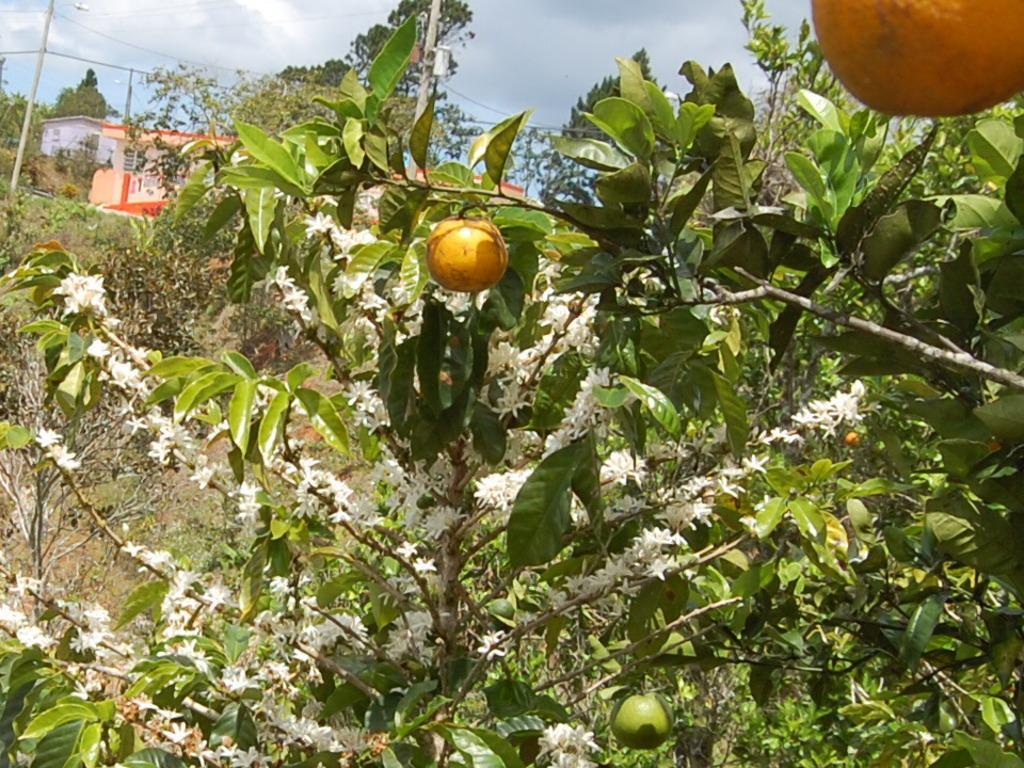How would you summarize this image in a sentence or two? In the foreground of this image, there are oranges to a tree and also few white color flowers to another tree. In the background, there are trees, two houses, poles, cables and the sky. 